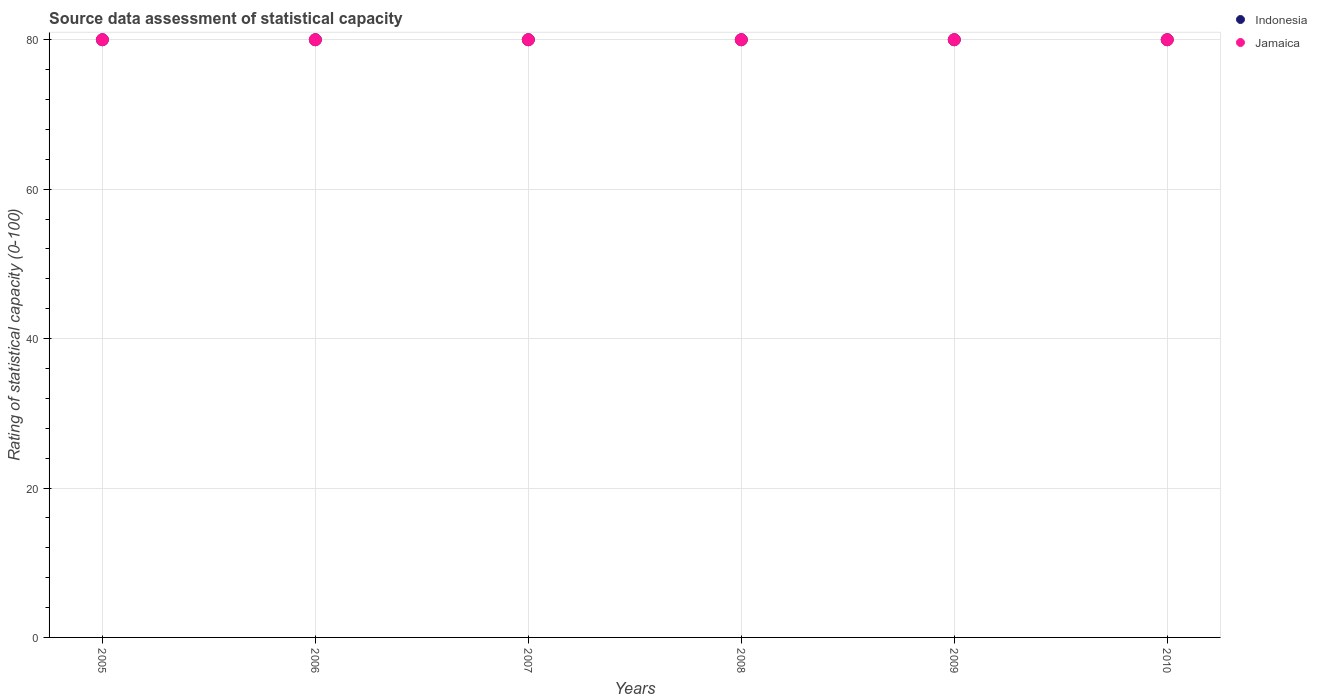How many different coloured dotlines are there?
Offer a very short reply. 2. What is the rating of statistical capacity in Jamaica in 2005?
Provide a succinct answer. 80. Across all years, what is the maximum rating of statistical capacity in Jamaica?
Ensure brevity in your answer.  80. Across all years, what is the minimum rating of statistical capacity in Jamaica?
Your response must be concise. 80. In which year was the rating of statistical capacity in Indonesia maximum?
Your answer should be compact. 2005. In which year was the rating of statistical capacity in Indonesia minimum?
Provide a short and direct response. 2005. What is the total rating of statistical capacity in Indonesia in the graph?
Ensure brevity in your answer.  480. In how many years, is the rating of statistical capacity in Indonesia greater than 32?
Keep it short and to the point. 6. What is the ratio of the rating of statistical capacity in Indonesia in 2006 to that in 2007?
Offer a very short reply. 1. What is the difference between the highest and the lowest rating of statistical capacity in Jamaica?
Give a very brief answer. 0. Is the rating of statistical capacity in Indonesia strictly less than the rating of statistical capacity in Jamaica over the years?
Give a very brief answer. No. How many years are there in the graph?
Offer a terse response. 6. Does the graph contain any zero values?
Offer a terse response. No. How many legend labels are there?
Provide a succinct answer. 2. What is the title of the graph?
Make the answer very short. Source data assessment of statistical capacity. Does "Iraq" appear as one of the legend labels in the graph?
Ensure brevity in your answer.  No. What is the label or title of the Y-axis?
Your response must be concise. Rating of statistical capacity (0-100). What is the Rating of statistical capacity (0-100) of Indonesia in 2005?
Your answer should be compact. 80. What is the Rating of statistical capacity (0-100) in Indonesia in 2006?
Offer a terse response. 80. What is the Rating of statistical capacity (0-100) in Jamaica in 2007?
Ensure brevity in your answer.  80. What is the Rating of statistical capacity (0-100) of Jamaica in 2008?
Your response must be concise. 80. What is the Rating of statistical capacity (0-100) of Indonesia in 2010?
Your response must be concise. 80. What is the Rating of statistical capacity (0-100) of Jamaica in 2010?
Your answer should be compact. 80. Across all years, what is the minimum Rating of statistical capacity (0-100) of Jamaica?
Your answer should be very brief. 80. What is the total Rating of statistical capacity (0-100) of Indonesia in the graph?
Your answer should be compact. 480. What is the total Rating of statistical capacity (0-100) of Jamaica in the graph?
Ensure brevity in your answer.  480. What is the difference between the Rating of statistical capacity (0-100) in Indonesia in 2005 and that in 2006?
Make the answer very short. 0. What is the difference between the Rating of statistical capacity (0-100) in Indonesia in 2005 and that in 2008?
Provide a succinct answer. 0. What is the difference between the Rating of statistical capacity (0-100) of Indonesia in 2005 and that in 2009?
Your answer should be compact. 0. What is the difference between the Rating of statistical capacity (0-100) in Jamaica in 2005 and that in 2009?
Your response must be concise. 0. What is the difference between the Rating of statistical capacity (0-100) in Indonesia in 2005 and that in 2010?
Provide a succinct answer. 0. What is the difference between the Rating of statistical capacity (0-100) of Jamaica in 2005 and that in 2010?
Provide a short and direct response. 0. What is the difference between the Rating of statistical capacity (0-100) of Indonesia in 2006 and that in 2007?
Ensure brevity in your answer.  0. What is the difference between the Rating of statistical capacity (0-100) of Jamaica in 2006 and that in 2008?
Your response must be concise. 0. What is the difference between the Rating of statistical capacity (0-100) in Indonesia in 2006 and that in 2009?
Offer a terse response. 0. What is the difference between the Rating of statistical capacity (0-100) of Jamaica in 2006 and that in 2009?
Your answer should be very brief. 0. What is the difference between the Rating of statistical capacity (0-100) of Indonesia in 2006 and that in 2010?
Your answer should be very brief. 0. What is the difference between the Rating of statistical capacity (0-100) of Indonesia in 2007 and that in 2008?
Give a very brief answer. 0. What is the difference between the Rating of statistical capacity (0-100) of Jamaica in 2007 and that in 2008?
Offer a terse response. 0. What is the difference between the Rating of statistical capacity (0-100) in Indonesia in 2007 and that in 2009?
Your answer should be very brief. 0. What is the difference between the Rating of statistical capacity (0-100) of Jamaica in 2008 and that in 2009?
Make the answer very short. 0. What is the difference between the Rating of statistical capacity (0-100) in Indonesia in 2008 and that in 2010?
Give a very brief answer. 0. What is the difference between the Rating of statistical capacity (0-100) of Jamaica in 2009 and that in 2010?
Give a very brief answer. 0. What is the difference between the Rating of statistical capacity (0-100) in Indonesia in 2005 and the Rating of statistical capacity (0-100) in Jamaica in 2006?
Your answer should be very brief. 0. What is the difference between the Rating of statistical capacity (0-100) of Indonesia in 2005 and the Rating of statistical capacity (0-100) of Jamaica in 2007?
Make the answer very short. 0. What is the difference between the Rating of statistical capacity (0-100) of Indonesia in 2005 and the Rating of statistical capacity (0-100) of Jamaica in 2008?
Provide a succinct answer. 0. What is the difference between the Rating of statistical capacity (0-100) in Indonesia in 2005 and the Rating of statistical capacity (0-100) in Jamaica in 2009?
Make the answer very short. 0. What is the difference between the Rating of statistical capacity (0-100) in Indonesia in 2006 and the Rating of statistical capacity (0-100) in Jamaica in 2007?
Your answer should be very brief. 0. What is the difference between the Rating of statistical capacity (0-100) of Indonesia in 2006 and the Rating of statistical capacity (0-100) of Jamaica in 2010?
Keep it short and to the point. 0. What is the difference between the Rating of statistical capacity (0-100) of Indonesia in 2007 and the Rating of statistical capacity (0-100) of Jamaica in 2009?
Make the answer very short. 0. What is the difference between the Rating of statistical capacity (0-100) of Indonesia in 2008 and the Rating of statistical capacity (0-100) of Jamaica in 2009?
Provide a succinct answer. 0. What is the difference between the Rating of statistical capacity (0-100) in Indonesia in 2008 and the Rating of statistical capacity (0-100) in Jamaica in 2010?
Keep it short and to the point. 0. What is the difference between the Rating of statistical capacity (0-100) in Indonesia in 2009 and the Rating of statistical capacity (0-100) in Jamaica in 2010?
Keep it short and to the point. 0. What is the average Rating of statistical capacity (0-100) of Indonesia per year?
Keep it short and to the point. 80. What is the average Rating of statistical capacity (0-100) of Jamaica per year?
Your response must be concise. 80. In the year 2009, what is the difference between the Rating of statistical capacity (0-100) of Indonesia and Rating of statistical capacity (0-100) of Jamaica?
Provide a short and direct response. 0. In the year 2010, what is the difference between the Rating of statistical capacity (0-100) in Indonesia and Rating of statistical capacity (0-100) in Jamaica?
Offer a terse response. 0. What is the ratio of the Rating of statistical capacity (0-100) in Indonesia in 2005 to that in 2006?
Provide a succinct answer. 1. What is the ratio of the Rating of statistical capacity (0-100) of Jamaica in 2005 to that in 2006?
Give a very brief answer. 1. What is the ratio of the Rating of statistical capacity (0-100) of Jamaica in 2005 to that in 2007?
Make the answer very short. 1. What is the ratio of the Rating of statistical capacity (0-100) of Indonesia in 2005 to that in 2008?
Your answer should be compact. 1. What is the ratio of the Rating of statistical capacity (0-100) in Jamaica in 2005 to that in 2008?
Offer a very short reply. 1. What is the ratio of the Rating of statistical capacity (0-100) of Indonesia in 2005 to that in 2009?
Make the answer very short. 1. What is the ratio of the Rating of statistical capacity (0-100) of Indonesia in 2005 to that in 2010?
Provide a short and direct response. 1. What is the ratio of the Rating of statistical capacity (0-100) of Indonesia in 2006 to that in 2007?
Give a very brief answer. 1. What is the ratio of the Rating of statistical capacity (0-100) in Indonesia in 2006 to that in 2009?
Keep it short and to the point. 1. What is the ratio of the Rating of statistical capacity (0-100) in Indonesia in 2006 to that in 2010?
Your answer should be very brief. 1. What is the ratio of the Rating of statistical capacity (0-100) of Indonesia in 2007 to that in 2008?
Make the answer very short. 1. What is the ratio of the Rating of statistical capacity (0-100) in Indonesia in 2007 to that in 2009?
Ensure brevity in your answer.  1. What is the ratio of the Rating of statistical capacity (0-100) of Jamaica in 2007 to that in 2010?
Give a very brief answer. 1. What is the ratio of the Rating of statistical capacity (0-100) of Indonesia in 2008 to that in 2009?
Make the answer very short. 1. What is the ratio of the Rating of statistical capacity (0-100) of Jamaica in 2008 to that in 2009?
Offer a very short reply. 1. What is the ratio of the Rating of statistical capacity (0-100) in Jamaica in 2008 to that in 2010?
Your answer should be compact. 1. What is the difference between the highest and the second highest Rating of statistical capacity (0-100) in Indonesia?
Ensure brevity in your answer.  0. What is the difference between the highest and the second highest Rating of statistical capacity (0-100) of Jamaica?
Your answer should be very brief. 0. 